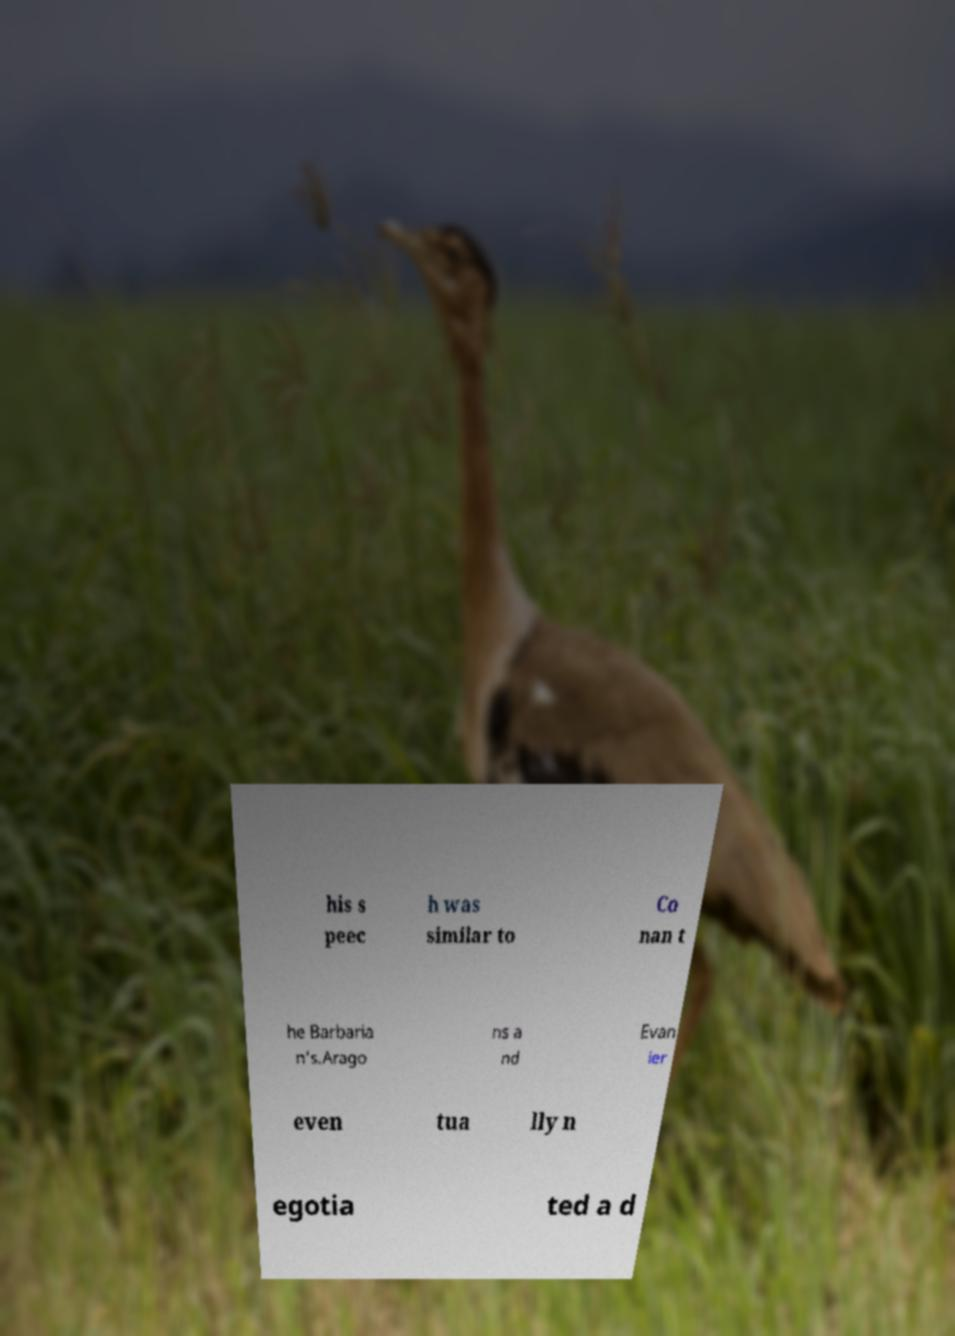Please read and relay the text visible in this image. What does it say? his s peec h was similar to Co nan t he Barbaria n's.Arago ns a nd Evan ier even tua lly n egotia ted a d 